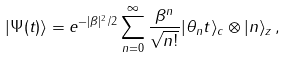Convert formula to latex. <formula><loc_0><loc_0><loc_500><loc_500>| \Psi ( t ) \rangle = e ^ { - | \beta | ^ { 2 } / 2 } \sum ^ { \infty } _ { n = 0 } \frac { \beta ^ { n } } { \sqrt { n ! } } | \theta _ { n } t \rangle _ { c } \otimes | n \rangle _ { z } \, ,</formula> 